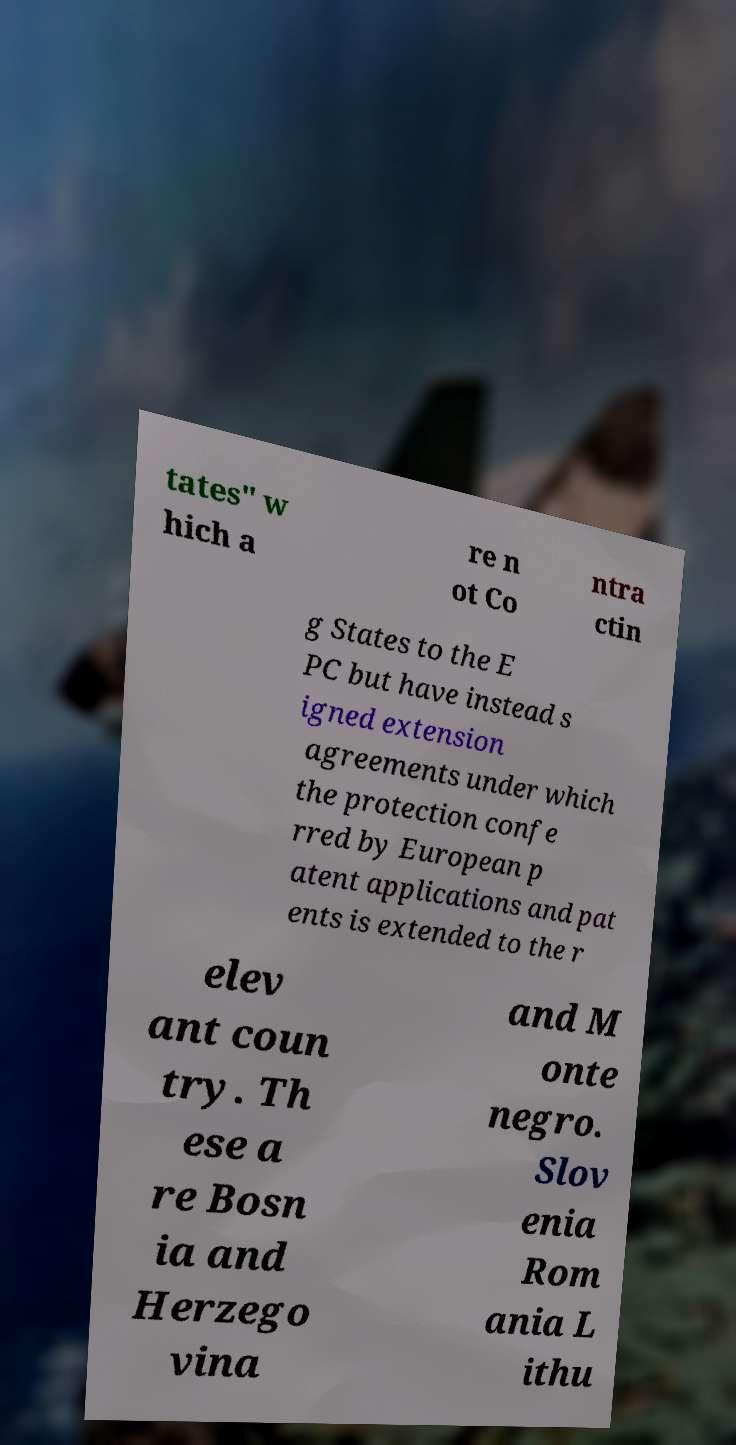Can you read and provide the text displayed in the image?This photo seems to have some interesting text. Can you extract and type it out for me? tates" w hich a re n ot Co ntra ctin g States to the E PC but have instead s igned extension agreements under which the protection confe rred by European p atent applications and pat ents is extended to the r elev ant coun try. Th ese a re Bosn ia and Herzego vina and M onte negro. Slov enia Rom ania L ithu 